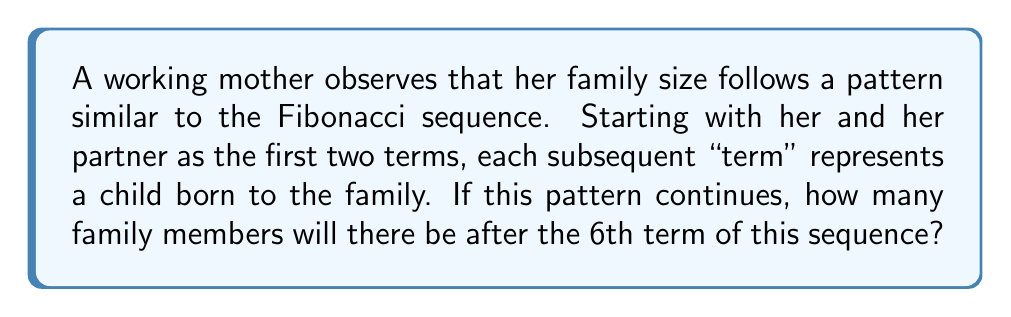Provide a solution to this math problem. Let's approach this step-by-step:

1) The Fibonacci sequence is defined as follows:
   $F_n = F_{n-1} + F_{n-2}$, where $F_1 = 1$ and $F_2 = 1$

2) In this family's case, we start with:
   $F_1 = 1$ (the mother)
   $F_2 = 1$ (the partner)

3) Let's calculate the subsequent terms:
   $F_3 = F_2 + F_1 = 1 + 1 = 2$ (first child)
   $F_4 = F_3 + F_2 = 2 + 1 = 3$ (second child)
   $F_5 = F_4 + F_3 = 3 + 2 = 5$ (third child)
   $F_6 = F_5 + F_4 = 5 + 3 = 8$ (fourth child)

4) To find the total number of family members, we need to sum up all terms from $F_1$ to $F_6$:

   $\sum_{i=1}^6 F_i = 1 + 1 + 2 + 3 + 5 + 8 = 20$

Therefore, after the 6th term, there will be 20 family members in total.
Answer: 20 